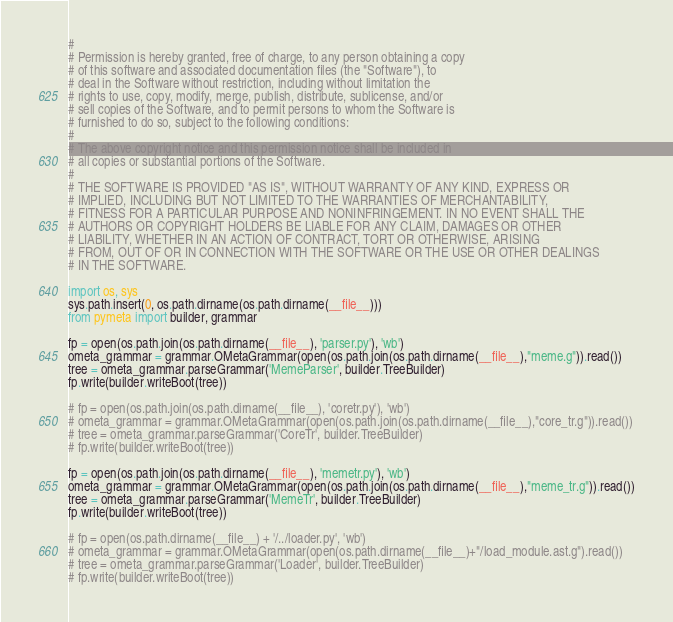Convert code to text. <code><loc_0><loc_0><loc_500><loc_500><_Python_>#
# Permission is hereby granted, free of charge, to any person obtaining a copy
# of this software and associated documentation files (the "Software"), to
# deal in the Software without restriction, including without limitation the
# rights to use, copy, modify, merge, publish, distribute, sublicense, and/or
# sell copies of the Software, and to permit persons to whom the Software is
# furnished to do so, subject to the following conditions:
#
# The above copyright notice and this permission notice shall be included in
# all copies or substantial portions of the Software.
#
# THE SOFTWARE IS PROVIDED "AS IS", WITHOUT WARRANTY OF ANY KIND, EXPRESS OR
# IMPLIED, INCLUDING BUT NOT LIMITED TO THE WARRANTIES OF MERCHANTABILITY,
# FITNESS FOR A PARTICULAR PURPOSE AND NONINFRINGEMENT. IN NO EVENT SHALL THE
# AUTHORS OR COPYRIGHT HOLDERS BE LIABLE FOR ANY CLAIM, DAMAGES OR OTHER
# LIABILITY, WHETHER IN AN ACTION OF CONTRACT, TORT OR OTHERWISE, ARISING
# FROM, OUT OF OR IN CONNECTION WITH THE SOFTWARE OR THE USE OR OTHER DEALINGS
# IN THE SOFTWARE.

import os, sys
sys.path.insert(0, os.path.dirname(os.path.dirname(__file__)))
from pymeta import builder, grammar

fp = open(os.path.join(os.path.dirname(__file__), 'parser.py'), 'wb')
ometa_grammar = grammar.OMetaGrammar(open(os.path.join(os.path.dirname(__file__),"meme.g")).read())
tree = ometa_grammar.parseGrammar('MemeParser', builder.TreeBuilder)
fp.write(builder.writeBoot(tree))

# fp = open(os.path.join(os.path.dirname(__file__), 'coretr.py'), 'wb')
# ometa_grammar = grammar.OMetaGrammar(open(os.path.join(os.path.dirname(__file__),"core_tr.g")).read())
# tree = ometa_grammar.parseGrammar('CoreTr', builder.TreeBuilder)
# fp.write(builder.writeBoot(tree))

fp = open(os.path.join(os.path.dirname(__file__), 'memetr.py'), 'wb')
ometa_grammar = grammar.OMetaGrammar(open(os.path.join(os.path.dirname(__file__),"meme_tr.g")).read())
tree = ometa_grammar.parseGrammar('MemeTr', builder.TreeBuilder)
fp.write(builder.writeBoot(tree))

# fp = open(os.path.dirname(__file__) + '/../loader.py', 'wb')
# ometa_grammar = grammar.OMetaGrammar(open(os.path.dirname(__file__)+"/load_module.ast.g").read())
# tree = ometa_grammar.parseGrammar('Loader', builder.TreeBuilder)
# fp.write(builder.writeBoot(tree))
</code> 